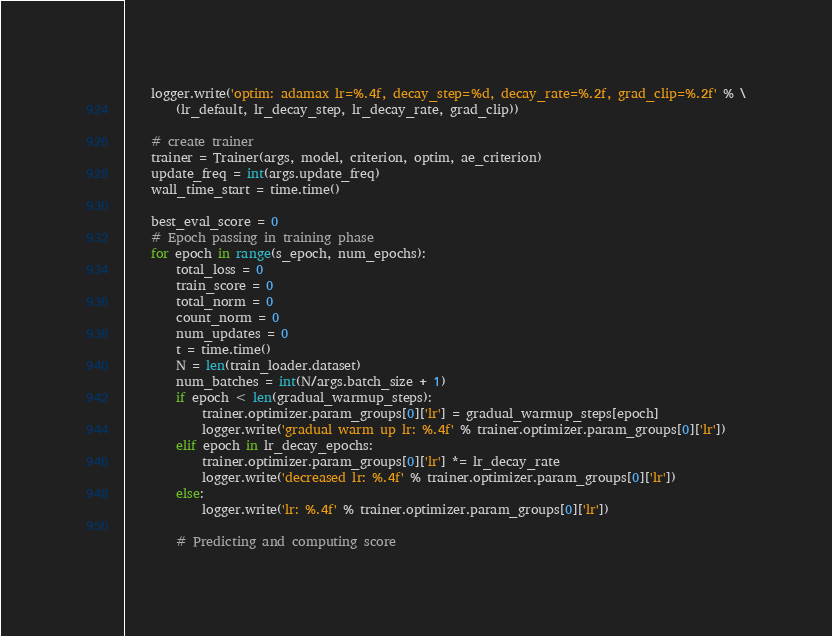Convert code to text. <code><loc_0><loc_0><loc_500><loc_500><_Python_>    logger.write('optim: adamax lr=%.4f, decay_step=%d, decay_rate=%.2f, grad_clip=%.2f' % \
        (lr_default, lr_decay_step, lr_decay_rate, grad_clip))

    # create trainer
    trainer = Trainer(args, model, criterion, optim, ae_criterion)
    update_freq = int(args.update_freq)
    wall_time_start = time.time()

    best_eval_score = 0
    # Epoch passing in training phase
    for epoch in range(s_epoch, num_epochs):
        total_loss = 0
        train_score = 0
        total_norm = 0
        count_norm = 0
        num_updates = 0
        t = time.time()
        N = len(train_loader.dataset)
        num_batches = int(N/args.batch_size + 1)
        if epoch < len(gradual_warmup_steps):
            trainer.optimizer.param_groups[0]['lr'] = gradual_warmup_steps[epoch]
            logger.write('gradual warm up lr: %.4f' % trainer.optimizer.param_groups[0]['lr'])
        elif epoch in lr_decay_epochs:
            trainer.optimizer.param_groups[0]['lr'] *= lr_decay_rate
            logger.write('decreased lr: %.4f' % trainer.optimizer.param_groups[0]['lr'])
        else:
            logger.write('lr: %.4f' % trainer.optimizer.param_groups[0]['lr'])

        # Predicting and computing score</code> 